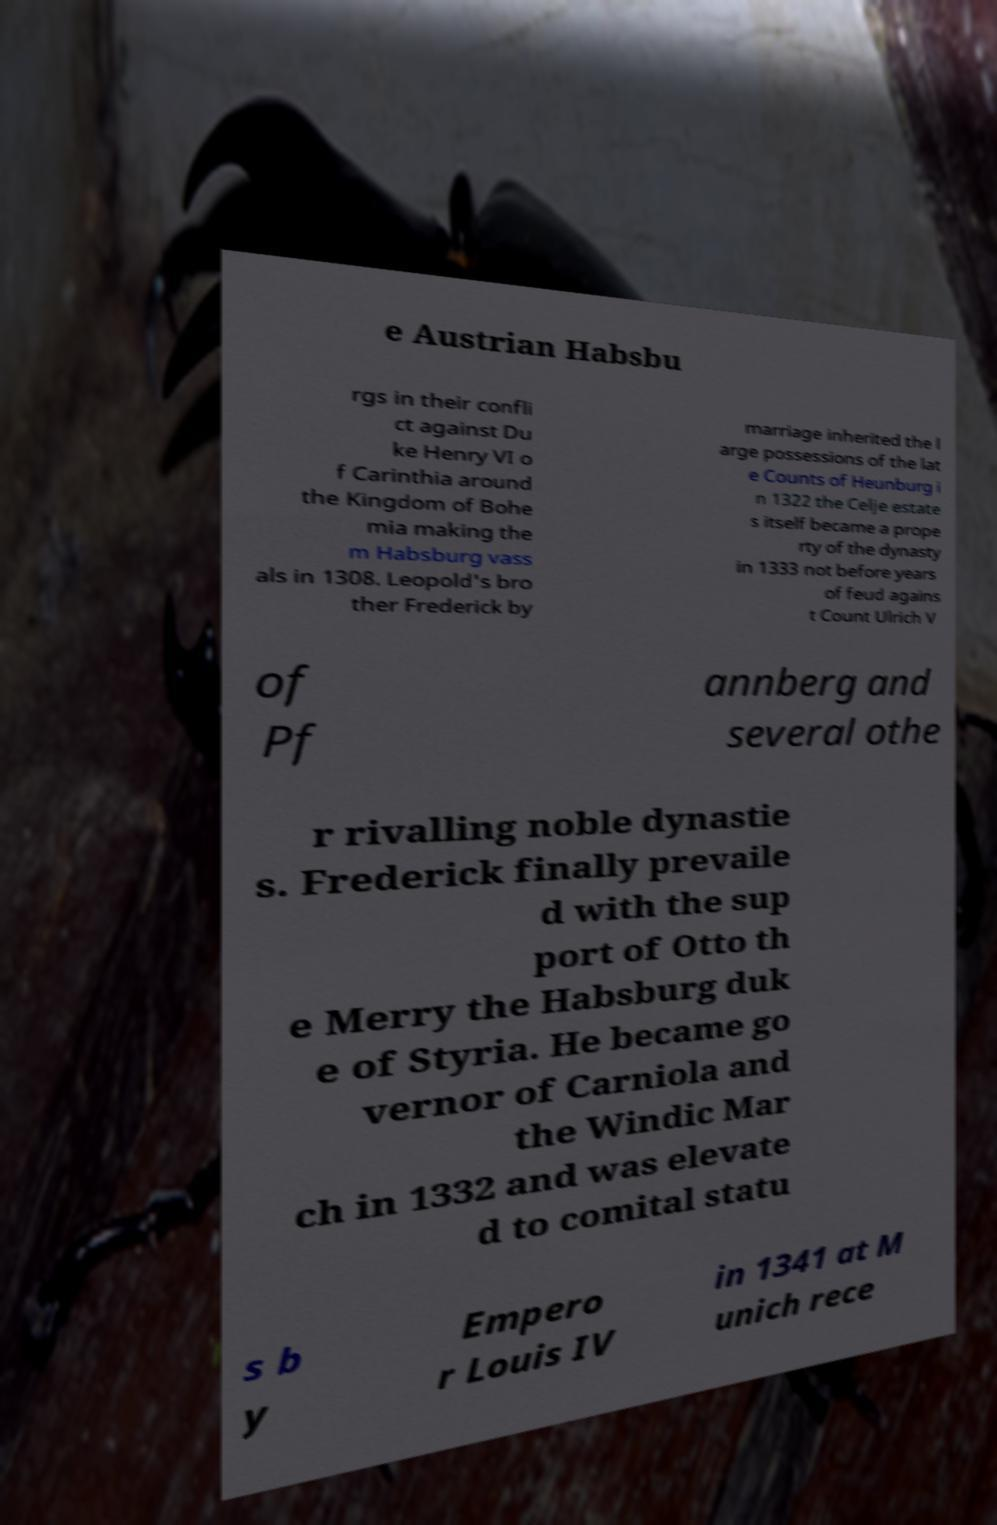There's text embedded in this image that I need extracted. Can you transcribe it verbatim? e Austrian Habsbu rgs in their confli ct against Du ke Henry VI o f Carinthia around the Kingdom of Bohe mia making the m Habsburg vass als in 1308. Leopold's bro ther Frederick by marriage inherited the l arge possessions of the lat e Counts of Heunburg i n 1322 the Celje estate s itself became a prope rty of the dynasty in 1333 not before years of feud agains t Count Ulrich V of Pf annberg and several othe r rivalling noble dynastie s. Frederick finally prevaile d with the sup port of Otto th e Merry the Habsburg duk e of Styria. He became go vernor of Carniola and the Windic Mar ch in 1332 and was elevate d to comital statu s b y Empero r Louis IV in 1341 at M unich rece 